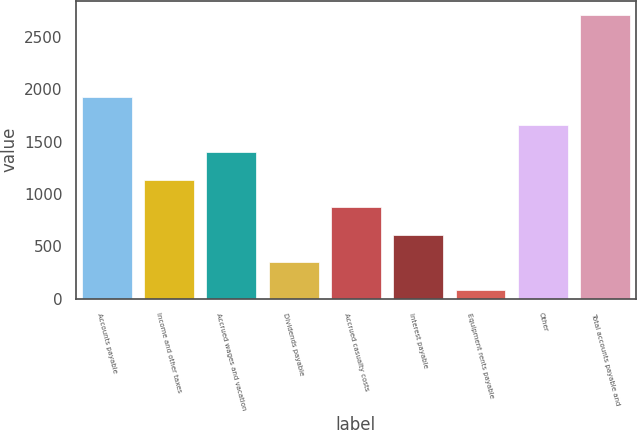Convert chart to OTSL. <chart><loc_0><loc_0><loc_500><loc_500><bar_chart><fcel>Accounts payable<fcel>Income and other taxes<fcel>Accrued wages and vacation<fcel>Dividends payable<fcel>Accrued casualty costs<fcel>Interest payable<fcel>Equipment rents payable<fcel>Other<fcel>Total accounts payable and<nl><fcel>1924.9<fcel>1136.8<fcel>1399.5<fcel>348.7<fcel>874.1<fcel>611.4<fcel>86<fcel>1662.2<fcel>2713<nl></chart> 